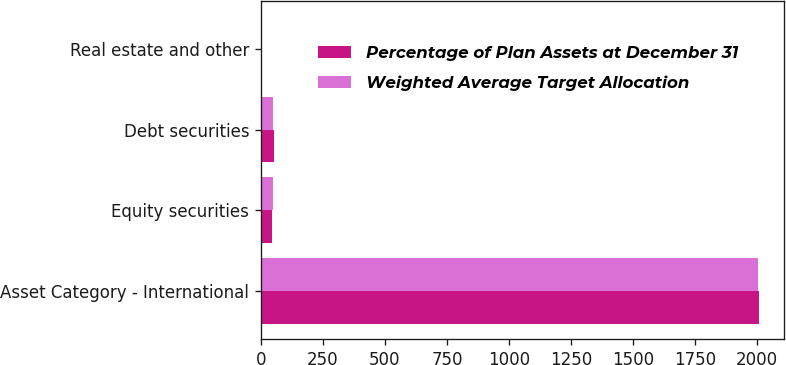Convert chart. <chart><loc_0><loc_0><loc_500><loc_500><stacked_bar_chart><ecel><fcel>Asset Category - International<fcel>Equity securities<fcel>Debt securities<fcel>Real estate and other<nl><fcel>Percentage of Plan Assets at December 31<fcel>2007<fcel>45<fcel>53<fcel>2<nl><fcel>Weighted Average Target Allocation<fcel>2006<fcel>50<fcel>49<fcel>1<nl></chart> 